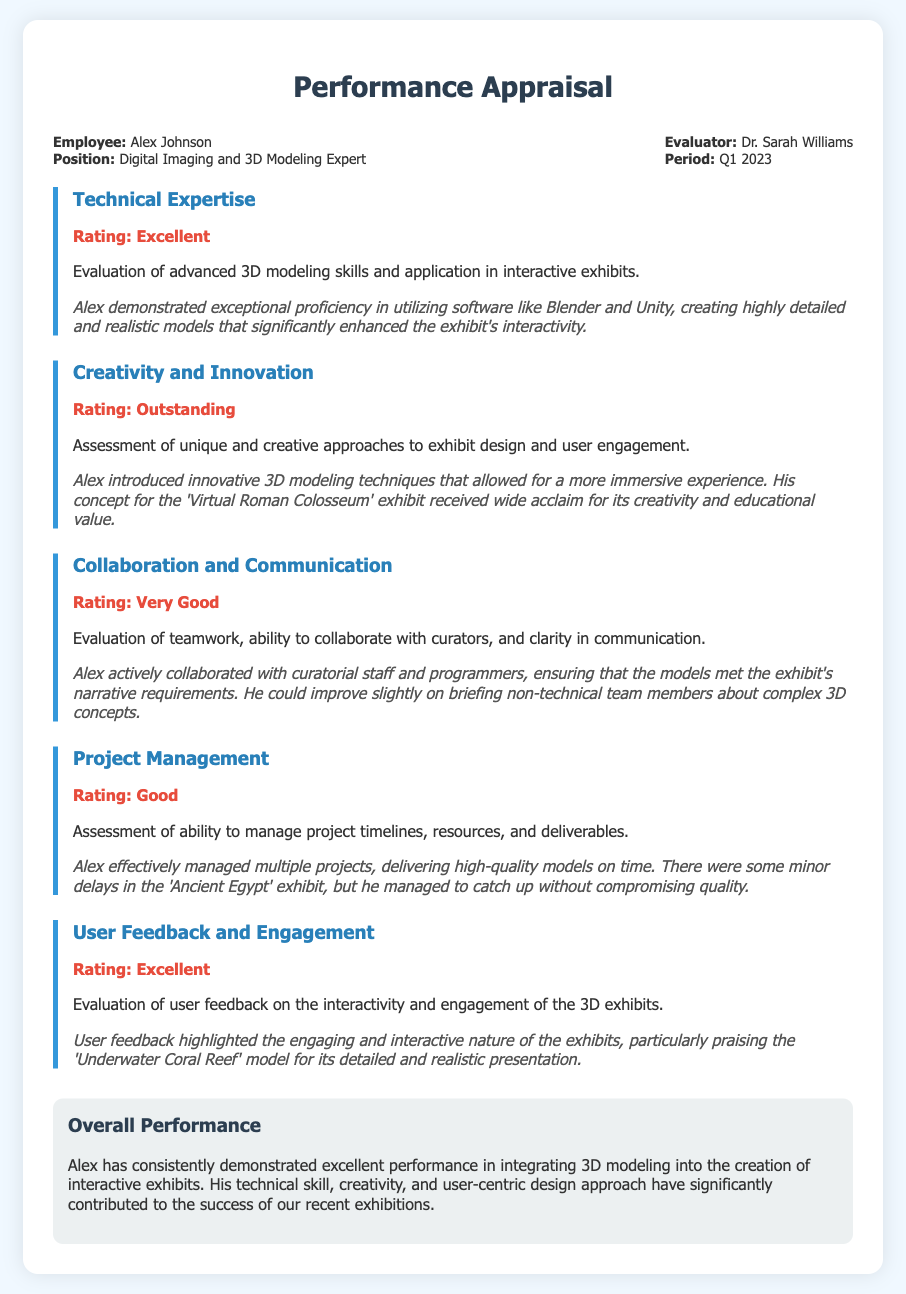What is the name of the employee being evaluated? The employee name is mentioned at the beginning of the document.
Answer: Alex Johnson What is the position of the employee? The position is specified in the header section of the document.
Answer: Digital Imaging and 3D Modeling Expert Who is the evaluator? The evaluator's name is provided in the header information.
Answer: Dr. Sarah Williams What is the rating for Technical Expertise? The rating can be found in the section dedicated to Technical Expertise.
Answer: Excellent What was the feedback for the 'Underwater Coral Reef' model? Feedback regarding the model can be found in the User Feedback and Engagement section.
Answer: Engaging and interactive What project experienced minor delays? The project name is included in the Project Management section of the document.
Answer: Ancient Egypt How did the evaluator rate Collaboration and Communication? The rating is clearly presented in the corresponding section.
Answer: Very Good What is the overall assessment of Alex's performance? The overall performance evaluation summarizes Alex's contributions at the end of the document.
Answer: Excellent performance What technique did Alex introduce in his creative approach? The specific technique is mentioned in the Creativity and Innovation section.
Answer: Innovative 3D modeling techniques 